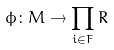Convert formula to latex. <formula><loc_0><loc_0><loc_500><loc_500>\phi \colon M \rightarrow \prod _ { i \in F } R</formula> 